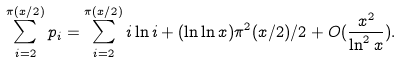Convert formula to latex. <formula><loc_0><loc_0><loc_500><loc_500>\sum _ { i = 2 } ^ { \pi ( x / 2 ) } p _ { i } = \sum _ { i = 2 } ^ { \pi ( x / 2 ) } i \ln i + ( \ln \ln x ) \pi ^ { 2 } ( x / 2 ) / 2 + O ( \frac { x ^ { 2 } } { \ln ^ { 2 } x } ) .</formula> 